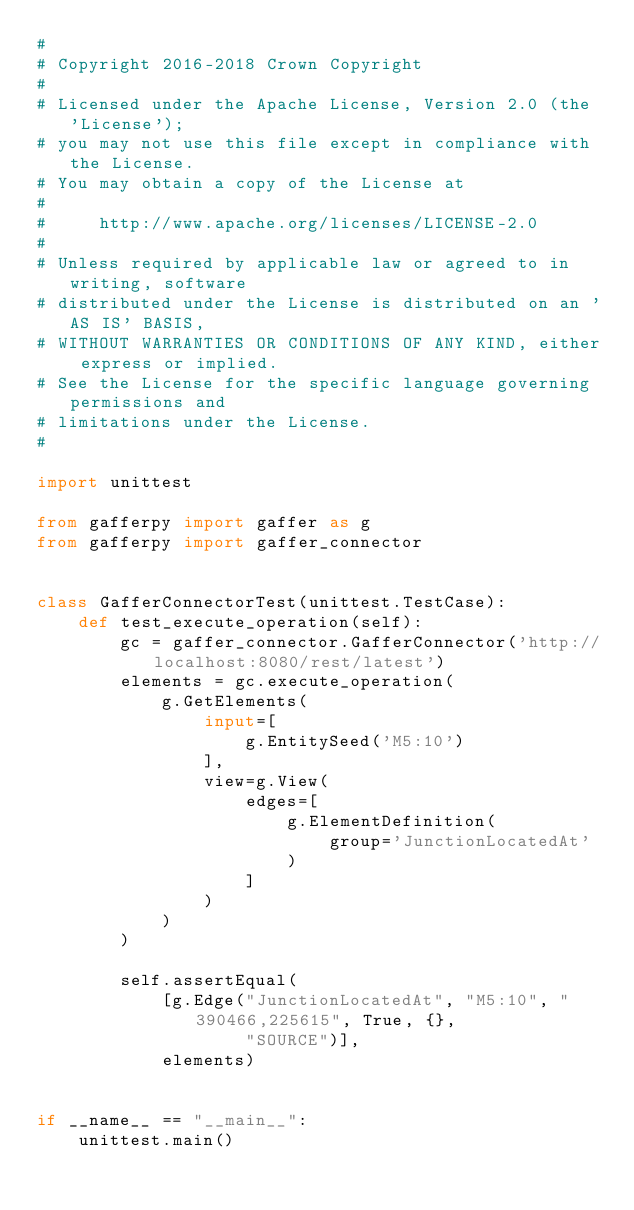Convert code to text. <code><loc_0><loc_0><loc_500><loc_500><_Python_>#
# Copyright 2016-2018 Crown Copyright
#
# Licensed under the Apache License, Version 2.0 (the 'License');
# you may not use this file except in compliance with the License.
# You may obtain a copy of the License at
#
#     http://www.apache.org/licenses/LICENSE-2.0
#
# Unless required by applicable law or agreed to in writing, software
# distributed under the License is distributed on an 'AS IS' BASIS,
# WITHOUT WARRANTIES OR CONDITIONS OF ANY KIND, either express or implied.
# See the License for the specific language governing permissions and
# limitations under the License.
#

import unittest

from gafferpy import gaffer as g
from gafferpy import gaffer_connector


class GafferConnectorTest(unittest.TestCase):
    def test_execute_operation(self):
        gc = gaffer_connector.GafferConnector('http://localhost:8080/rest/latest')
        elements = gc.execute_operation(
            g.GetElements(
                input=[
                    g.EntitySeed('M5:10')
                ],
                view=g.View(
                    edges=[
                        g.ElementDefinition(
                            group='JunctionLocatedAt'
                        )
                    ]
                )
            )
        )

        self.assertEqual(
            [g.Edge("JunctionLocatedAt", "M5:10", "390466,225615", True, {},
                    "SOURCE")],
            elements)


if __name__ == "__main__":
    unittest.main()
</code> 